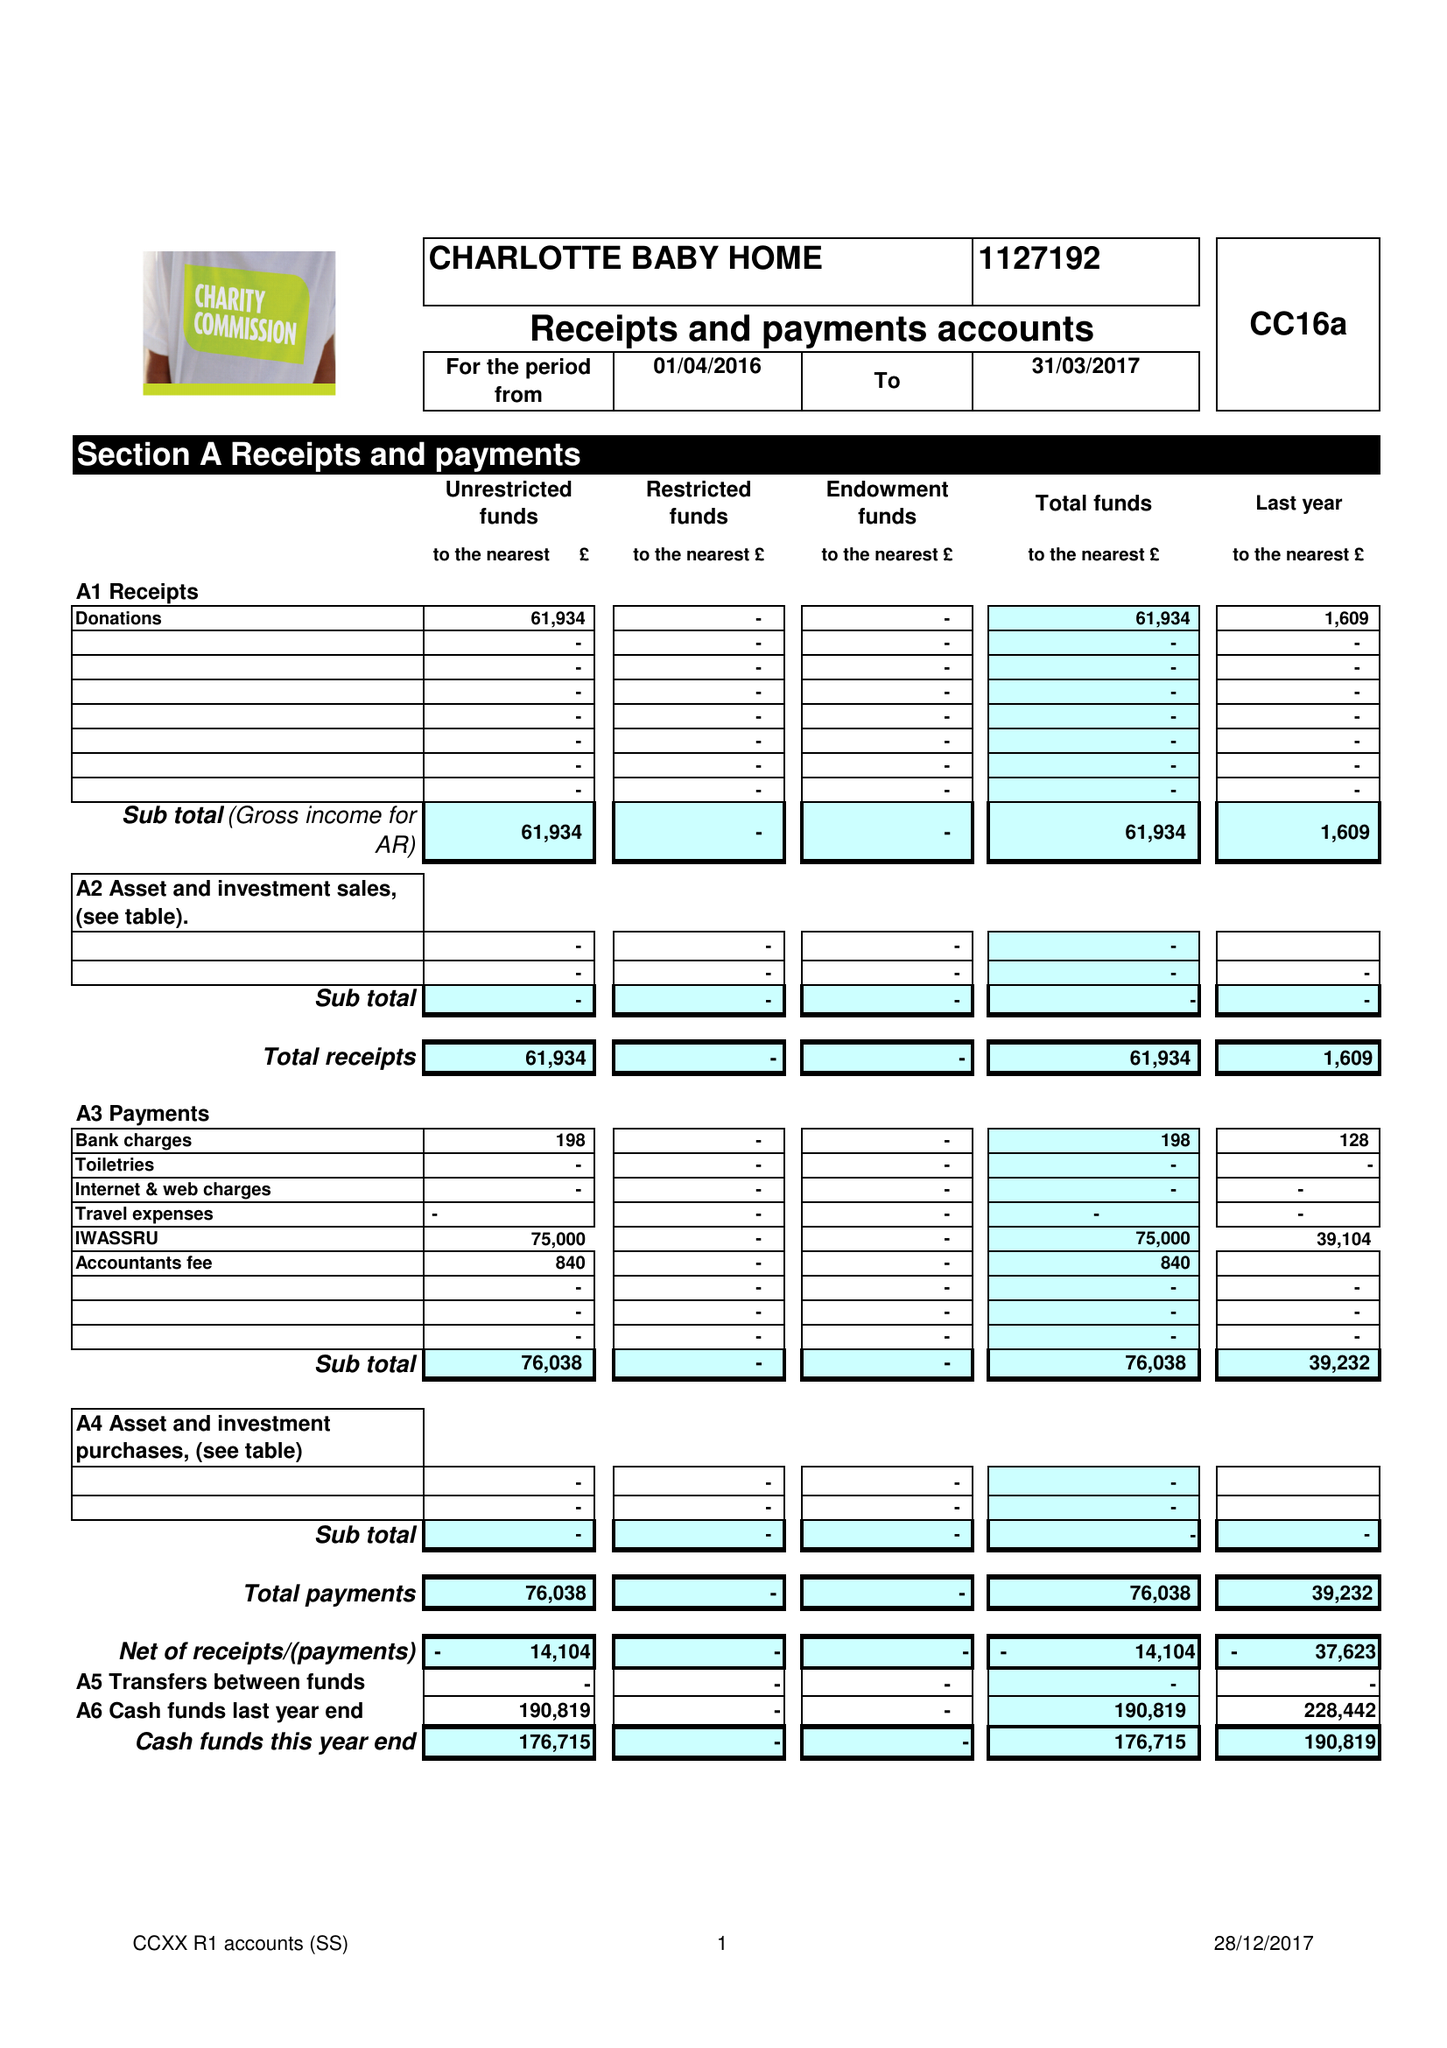What is the value for the income_annually_in_british_pounds?
Answer the question using a single word or phrase. 61934.00 